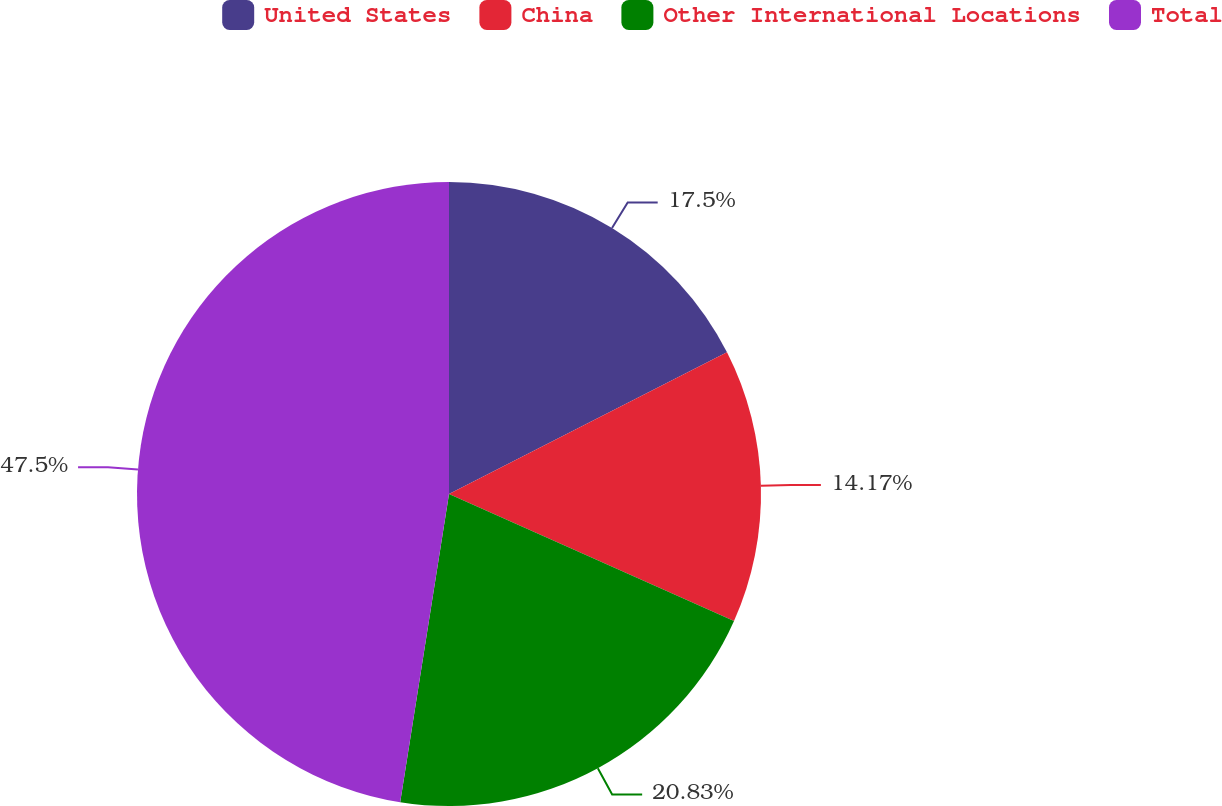Convert chart. <chart><loc_0><loc_0><loc_500><loc_500><pie_chart><fcel>United States<fcel>China<fcel>Other International Locations<fcel>Total<nl><fcel>17.5%<fcel>14.17%<fcel>20.83%<fcel>47.5%<nl></chart> 